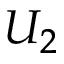<formula> <loc_0><loc_0><loc_500><loc_500>U _ { 2 }</formula> 